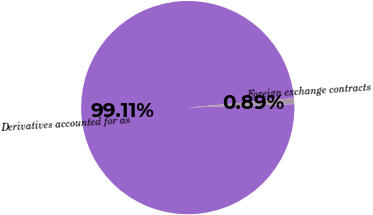Convert chart. <chart><loc_0><loc_0><loc_500><loc_500><pie_chart><fcel>Derivatives accounted for as<fcel>Foreign exchange contracts<nl><fcel>99.11%<fcel>0.89%<nl></chart> 